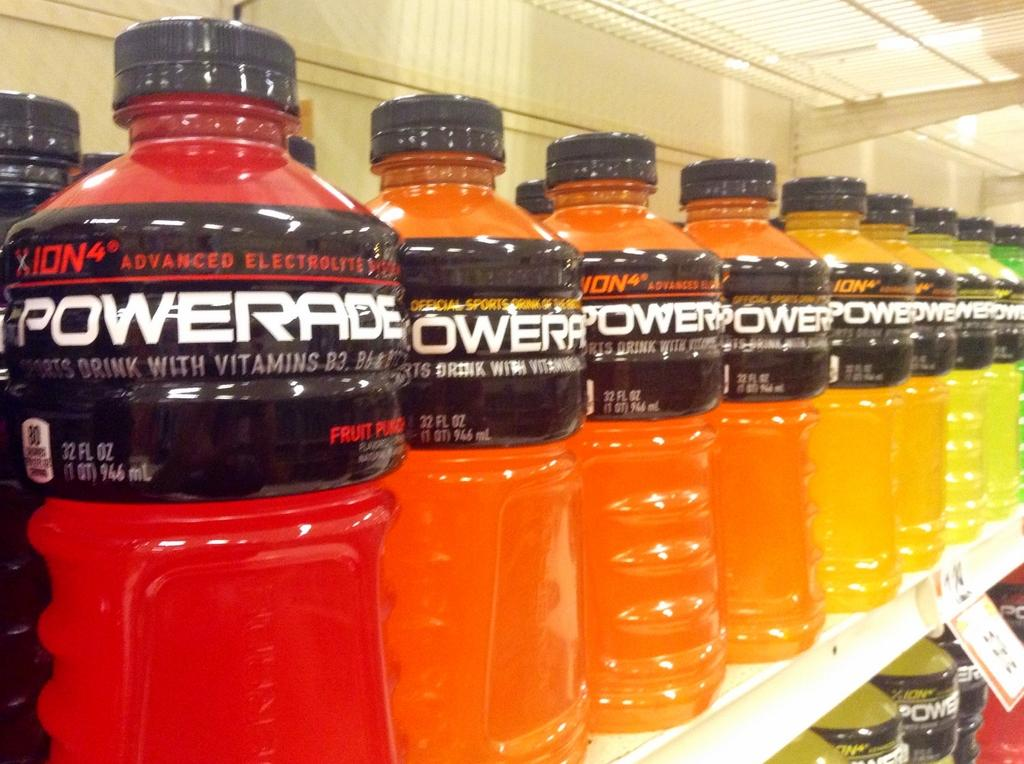<image>
Offer a succinct explanation of the picture presented. Many colored bottles of powerade line a shelf. 